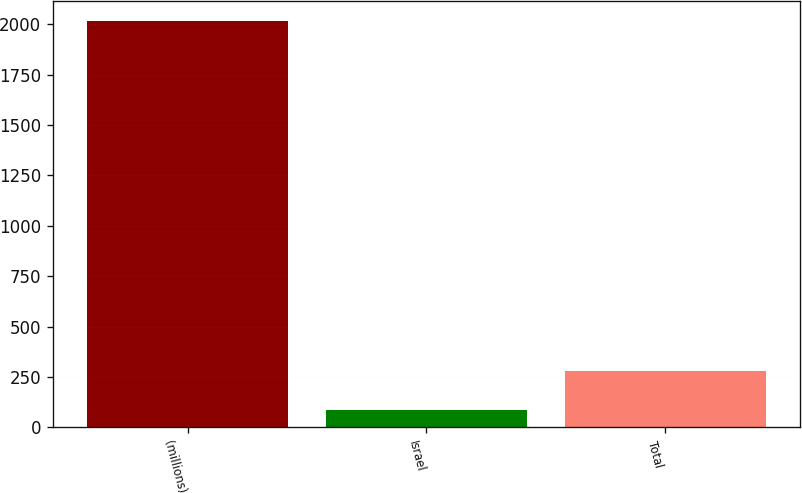Convert chart. <chart><loc_0><loc_0><loc_500><loc_500><bar_chart><fcel>(millions)<fcel>Israel<fcel>Total<nl><fcel>2016<fcel>88<fcel>280.8<nl></chart> 